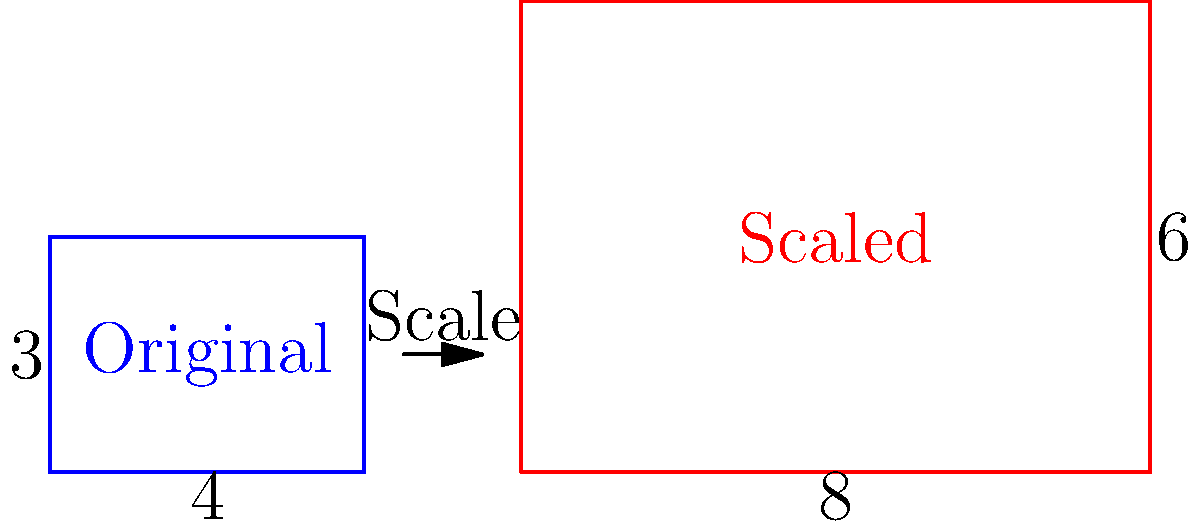A mobile app's user interface element needs to be scaled up for a larger screen. The original element has dimensions of 4 units width and 3 units height. If the width is increased to 8 units while maintaining the aspect ratio, what will be the new height of the scaled element? To solve this problem, we need to understand the concept of aspect ratio and scaling:

1. Aspect ratio is the proportional relationship between width and height.
2. To maintain aspect ratio, both dimensions must be scaled by the same factor.

Let's solve this step-by-step:

1. Calculate the scaling factor:
   * Original width = 4 units
   * New width = 8 units
   * Scaling factor = New width / Original width
   * Scaling factor = 8 / 4 = 2

2. Apply the scaling factor to the height:
   * Original height = 3 units
   * New height = Original height × Scaling factor
   * New height = 3 × 2 = 6 units

Therefore, to maintain the aspect ratio, when the width is doubled from 4 to 8 units, the height must also be doubled from 3 to 6 units.
Answer: 6 units 